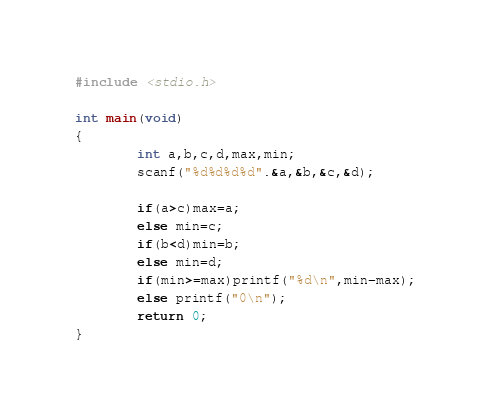Convert code to text. <code><loc_0><loc_0><loc_500><loc_500><_C_>#include <stdio.h>

int main(void)
{
        int a,b,c,d,max,min;
        scanf("%d%d%d%d".&a,&b,&c,&d);

        if(a>c)max=a;
        else min=c;
        if(b<d)min=b;
        else min=d;
        if(min>=max)printf("%d\n",min-max);
        else printf("0\n");
        return 0;
}
</code> 